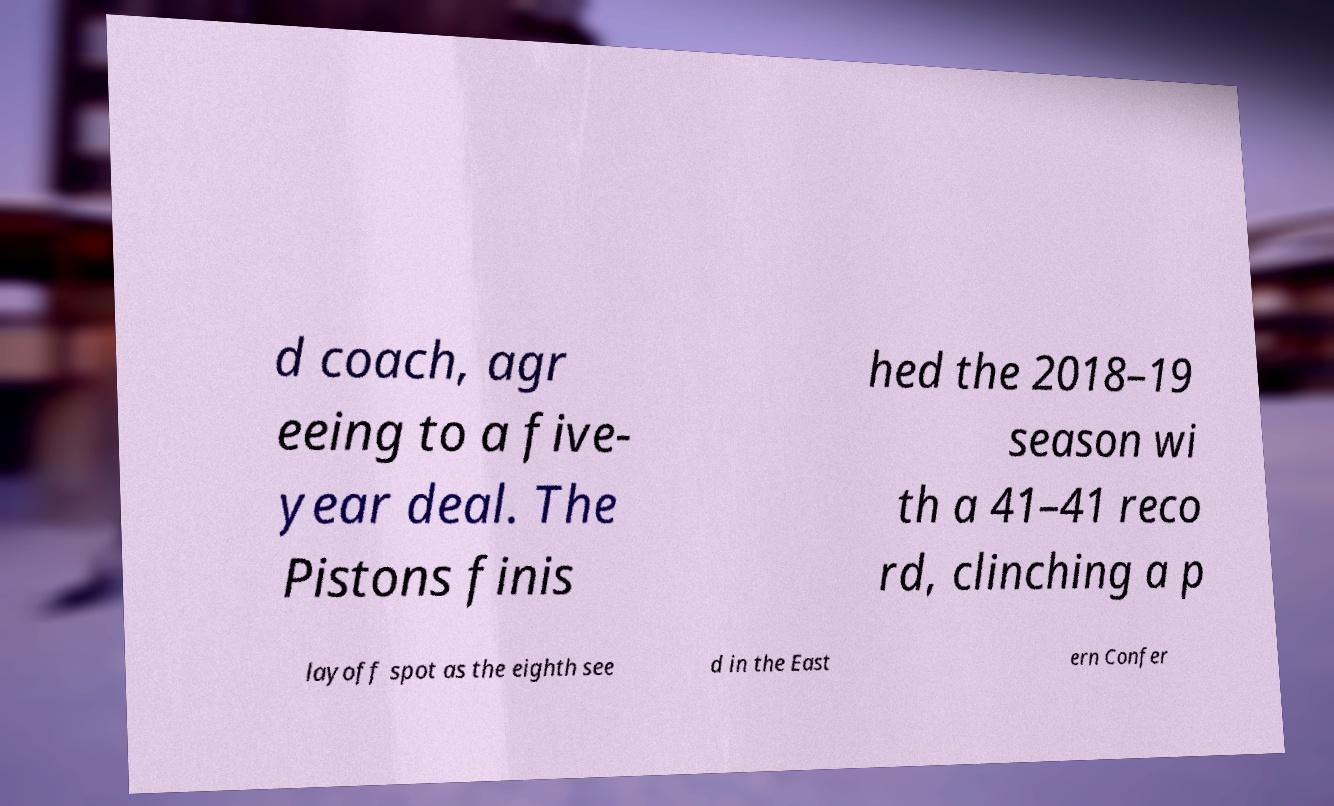Can you accurately transcribe the text from the provided image for me? d coach, agr eeing to a five- year deal. The Pistons finis hed the 2018–19 season wi th a 41–41 reco rd, clinching a p layoff spot as the eighth see d in the East ern Confer 